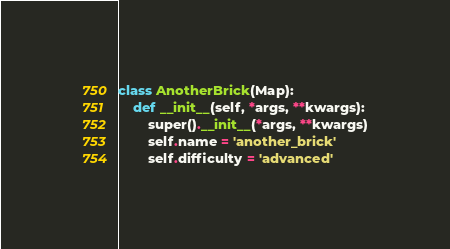Convert code to text. <code><loc_0><loc_0><loc_500><loc_500><_Python_>

class AnotherBrick(Map):
    def __init__(self, *args, **kwargs):
        super().__init__(*args, **kwargs)
        self.name = 'another_brick'
        self.difficulty = 'advanced'

</code> 